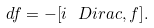Convert formula to latex. <formula><loc_0><loc_0><loc_500><loc_500>d f = - [ i \ D i r a c , f ] .</formula> 